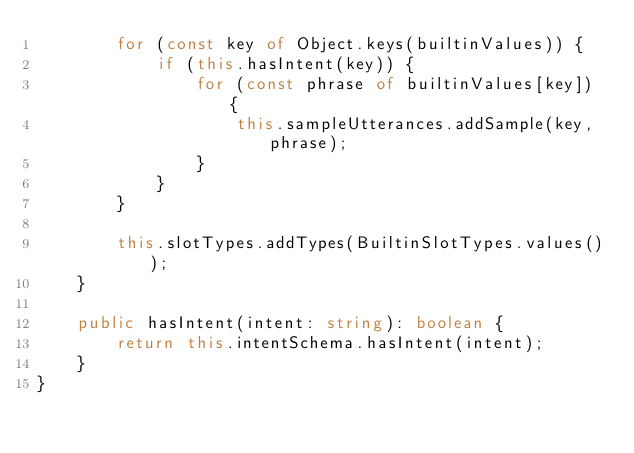<code> <loc_0><loc_0><loc_500><loc_500><_TypeScript_>        for (const key of Object.keys(builtinValues)) {
            if (this.hasIntent(key)) {
                for (const phrase of builtinValues[key]) {
                    this.sampleUtterances.addSample(key, phrase);
                }
            }
        }

        this.slotTypes.addTypes(BuiltinSlotTypes.values());
    }

    public hasIntent(intent: string): boolean {
        return this.intentSchema.hasIntent(intent);
    }
}
</code> 